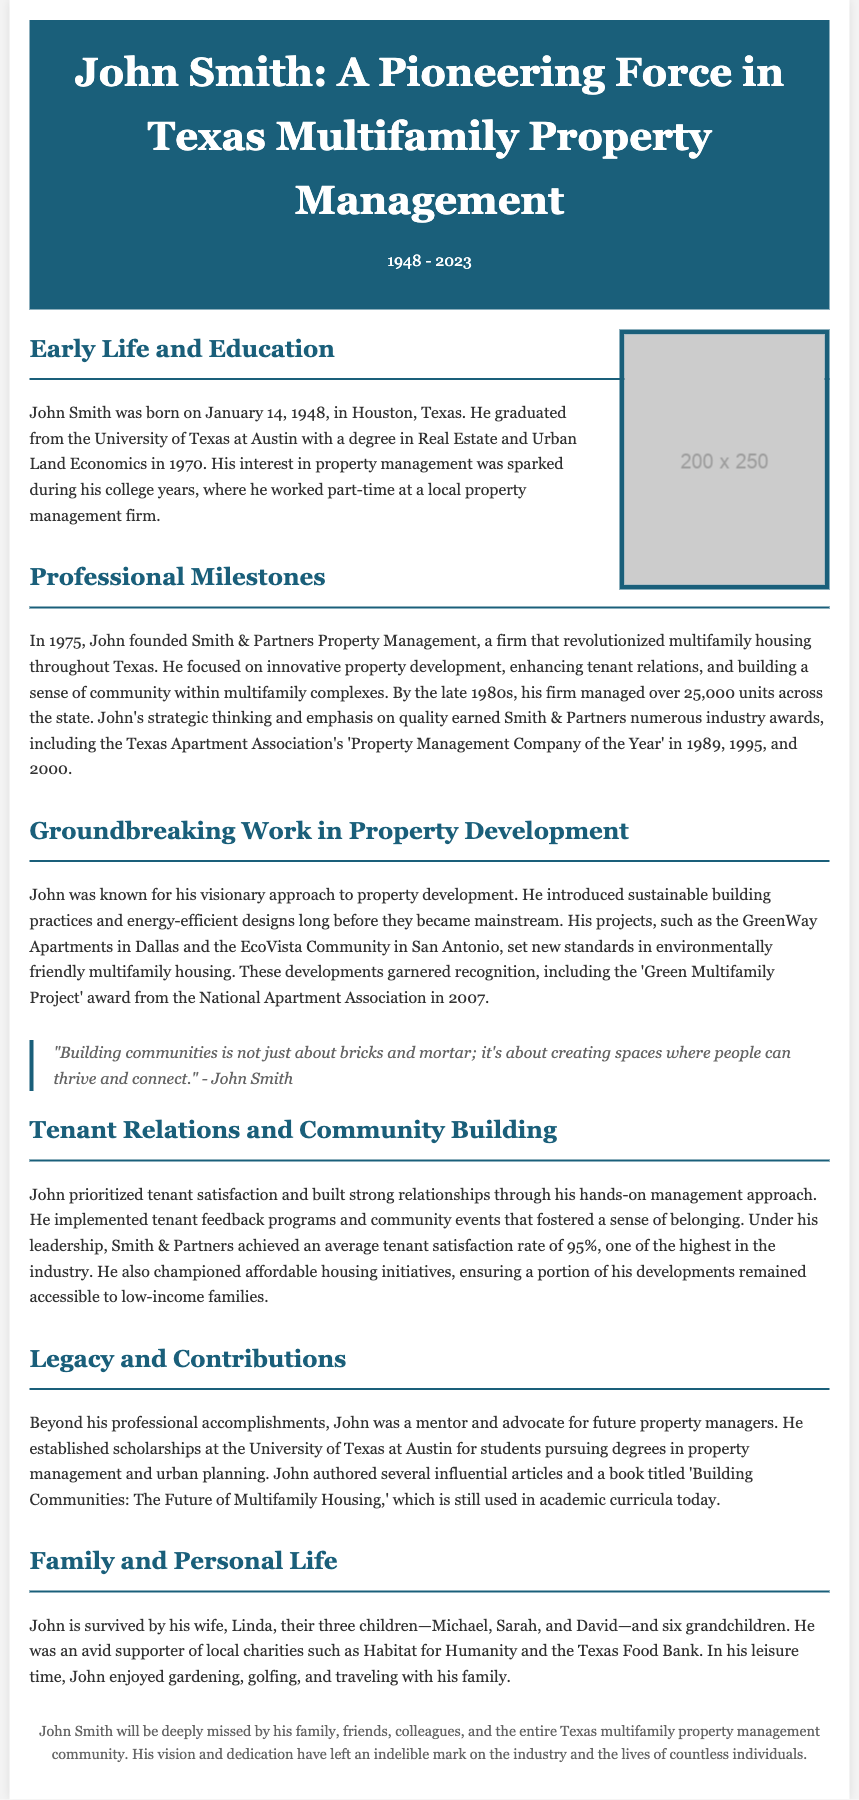Where was John Smith born? John Smith was born in Houston, Texas, as mentioned in the Early Life and Education section.
Answer: Houston, Texas What year did John Smith graduate from university? The document states that he graduated in 1970 from the University of Texas at Austin.
Answer: 1970 What was the name of the company John founded? According to the Professional Milestones section, he founded Smith & Partners Property Management.
Answer: Smith & Partners Property Management How many units did John’s firm manage by the late 1980s? The document indicates that by the late 1980s, his firm managed over 25,000 units.
Answer: over 25,000 units What award did John’s firm win in 1989? The document lists that Smith & Partners won the Texas Apartment Association's 'Property Management Company of the Year' award in 1989.
Answer: Property Management Company of the Year What approach did John prioritize regarding tenant relations? The document highlights that John prioritized tenant satisfaction through a hands-on management approach.
Answer: hands-on management approach What scholarship did John establish? John established scholarships at the University of Texas at Austin for students pursuing degrees in property management and urban planning, according to the Legacy and Contributions section.
Answer: scholarships for property management and urban planning What was the title of John’s book? The document states that John authored a book titled 'Building Communities: The Future of Multifamily Housing.'
Answer: Building Communities: The Future of Multifamily Housing What activities did John enjoy in his leisure time? The Personal Life section lists gardening, golfing, and traveling with his family as his leisure activities.
Answer: gardening, golfing, traveling with his family 